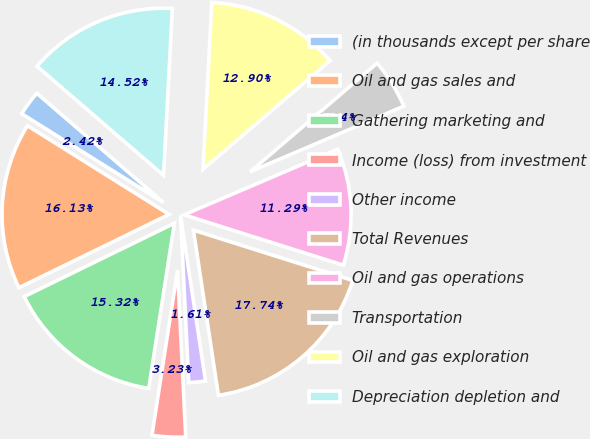Convert chart. <chart><loc_0><loc_0><loc_500><loc_500><pie_chart><fcel>(in thousands except per share<fcel>Oil and gas sales and<fcel>Gathering marketing and<fcel>Income (loss) from investment<fcel>Other income<fcel>Total Revenues<fcel>Oil and gas operations<fcel>Transportation<fcel>Oil and gas exploration<fcel>Depreciation depletion and<nl><fcel>2.42%<fcel>16.13%<fcel>15.32%<fcel>3.23%<fcel>1.61%<fcel>17.74%<fcel>11.29%<fcel>4.84%<fcel>12.9%<fcel>14.52%<nl></chart> 